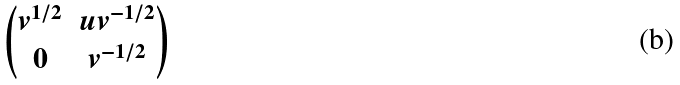<formula> <loc_0><loc_0><loc_500><loc_500>\begin{pmatrix} v ^ { 1 / 2 } & u v ^ { - 1 / 2 } \\ 0 & v ^ { - 1 / 2 } \end{pmatrix}</formula> 